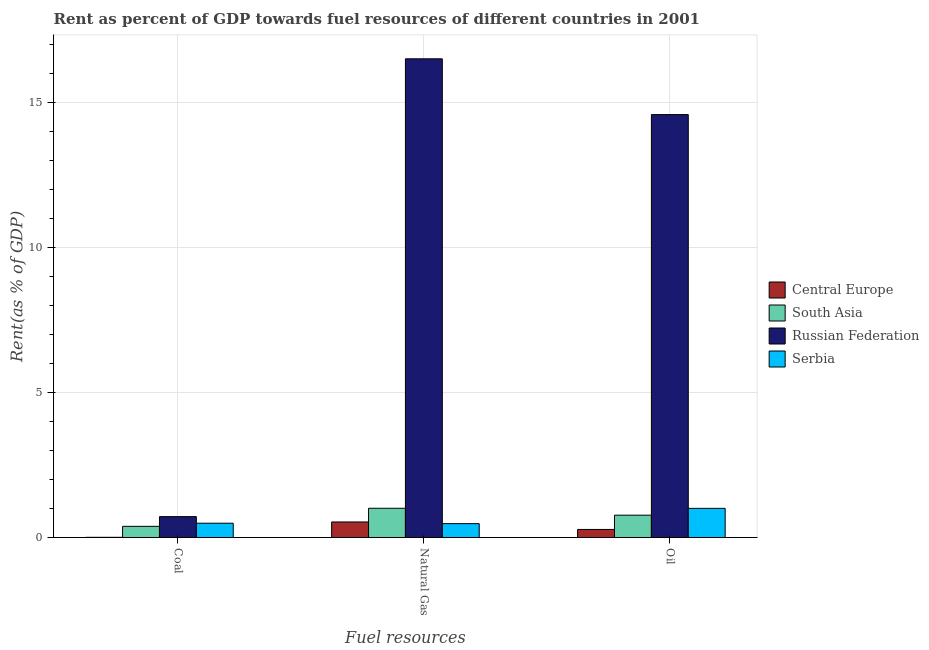How many different coloured bars are there?
Your response must be concise. 4. Are the number of bars per tick equal to the number of legend labels?
Your response must be concise. Yes. Are the number of bars on each tick of the X-axis equal?
Provide a succinct answer. Yes. How many bars are there on the 3rd tick from the right?
Offer a very short reply. 4. What is the label of the 1st group of bars from the left?
Ensure brevity in your answer.  Coal. What is the rent towards natural gas in Russian Federation?
Provide a succinct answer. 16.5. Across all countries, what is the maximum rent towards oil?
Provide a short and direct response. 14.57. Across all countries, what is the minimum rent towards coal?
Your answer should be very brief. 0.01. In which country was the rent towards coal maximum?
Provide a succinct answer. Russian Federation. In which country was the rent towards oil minimum?
Offer a terse response. Central Europe. What is the total rent towards natural gas in the graph?
Keep it short and to the point. 18.52. What is the difference between the rent towards coal in Central Europe and that in Russian Federation?
Keep it short and to the point. -0.71. What is the difference between the rent towards natural gas in Serbia and the rent towards oil in South Asia?
Keep it short and to the point. -0.29. What is the average rent towards coal per country?
Your answer should be compact. 0.4. What is the difference between the rent towards coal and rent towards natural gas in Serbia?
Offer a terse response. 0.01. What is the ratio of the rent towards oil in Central Europe to that in South Asia?
Ensure brevity in your answer.  0.36. Is the rent towards oil in Serbia less than that in South Asia?
Provide a succinct answer. No. Is the difference between the rent towards coal in Central Europe and South Asia greater than the difference between the rent towards oil in Central Europe and South Asia?
Offer a very short reply. Yes. What is the difference between the highest and the second highest rent towards natural gas?
Offer a very short reply. 15.49. What is the difference between the highest and the lowest rent towards coal?
Your response must be concise. 0.71. Is the sum of the rent towards coal in Russian Federation and Central Europe greater than the maximum rent towards natural gas across all countries?
Your answer should be very brief. No. What does the 4th bar from the left in Natural Gas represents?
Offer a very short reply. Serbia. What does the 2nd bar from the right in Coal represents?
Make the answer very short. Russian Federation. Are the values on the major ticks of Y-axis written in scientific E-notation?
Your answer should be very brief. No. Does the graph contain any zero values?
Your response must be concise. No. Does the graph contain grids?
Your answer should be very brief. Yes. How are the legend labels stacked?
Your answer should be compact. Vertical. What is the title of the graph?
Offer a very short reply. Rent as percent of GDP towards fuel resources of different countries in 2001. What is the label or title of the X-axis?
Give a very brief answer. Fuel resources. What is the label or title of the Y-axis?
Your answer should be very brief. Rent(as % of GDP). What is the Rent(as % of GDP) in Central Europe in Coal?
Offer a terse response. 0.01. What is the Rent(as % of GDP) in South Asia in Coal?
Ensure brevity in your answer.  0.38. What is the Rent(as % of GDP) in Russian Federation in Coal?
Provide a succinct answer. 0.72. What is the Rent(as % of GDP) of Serbia in Coal?
Offer a very short reply. 0.49. What is the Rent(as % of GDP) in Central Europe in Natural Gas?
Provide a succinct answer. 0.53. What is the Rent(as % of GDP) of South Asia in Natural Gas?
Give a very brief answer. 1.01. What is the Rent(as % of GDP) of Russian Federation in Natural Gas?
Offer a very short reply. 16.5. What is the Rent(as % of GDP) in Serbia in Natural Gas?
Make the answer very short. 0.48. What is the Rent(as % of GDP) in Central Europe in Oil?
Ensure brevity in your answer.  0.28. What is the Rent(as % of GDP) of South Asia in Oil?
Your answer should be compact. 0.77. What is the Rent(as % of GDP) in Russian Federation in Oil?
Offer a terse response. 14.57. What is the Rent(as % of GDP) in Serbia in Oil?
Offer a terse response. 1. Across all Fuel resources, what is the maximum Rent(as % of GDP) of Central Europe?
Offer a very short reply. 0.53. Across all Fuel resources, what is the maximum Rent(as % of GDP) in South Asia?
Offer a terse response. 1.01. Across all Fuel resources, what is the maximum Rent(as % of GDP) of Russian Federation?
Your answer should be very brief. 16.5. Across all Fuel resources, what is the maximum Rent(as % of GDP) in Serbia?
Offer a terse response. 1. Across all Fuel resources, what is the minimum Rent(as % of GDP) in Central Europe?
Provide a short and direct response. 0.01. Across all Fuel resources, what is the minimum Rent(as % of GDP) in South Asia?
Make the answer very short. 0.38. Across all Fuel resources, what is the minimum Rent(as % of GDP) of Russian Federation?
Your answer should be very brief. 0.72. Across all Fuel resources, what is the minimum Rent(as % of GDP) in Serbia?
Offer a terse response. 0.48. What is the total Rent(as % of GDP) in Central Europe in the graph?
Provide a short and direct response. 0.82. What is the total Rent(as % of GDP) in South Asia in the graph?
Keep it short and to the point. 2.16. What is the total Rent(as % of GDP) of Russian Federation in the graph?
Keep it short and to the point. 31.79. What is the total Rent(as % of GDP) in Serbia in the graph?
Offer a terse response. 1.97. What is the difference between the Rent(as % of GDP) in Central Europe in Coal and that in Natural Gas?
Your answer should be very brief. -0.53. What is the difference between the Rent(as % of GDP) of South Asia in Coal and that in Natural Gas?
Offer a very short reply. -0.62. What is the difference between the Rent(as % of GDP) of Russian Federation in Coal and that in Natural Gas?
Keep it short and to the point. -15.78. What is the difference between the Rent(as % of GDP) of Serbia in Coal and that in Natural Gas?
Your response must be concise. 0.01. What is the difference between the Rent(as % of GDP) in Central Europe in Coal and that in Oil?
Offer a terse response. -0.27. What is the difference between the Rent(as % of GDP) in South Asia in Coal and that in Oil?
Offer a terse response. -0.39. What is the difference between the Rent(as % of GDP) in Russian Federation in Coal and that in Oil?
Provide a succinct answer. -13.86. What is the difference between the Rent(as % of GDP) of Serbia in Coal and that in Oil?
Your answer should be very brief. -0.51. What is the difference between the Rent(as % of GDP) of Central Europe in Natural Gas and that in Oil?
Your answer should be very brief. 0.26. What is the difference between the Rent(as % of GDP) of South Asia in Natural Gas and that in Oil?
Offer a very short reply. 0.24. What is the difference between the Rent(as % of GDP) in Russian Federation in Natural Gas and that in Oil?
Provide a succinct answer. 1.92. What is the difference between the Rent(as % of GDP) in Serbia in Natural Gas and that in Oil?
Your response must be concise. -0.53. What is the difference between the Rent(as % of GDP) of Central Europe in Coal and the Rent(as % of GDP) of South Asia in Natural Gas?
Keep it short and to the point. -1. What is the difference between the Rent(as % of GDP) of Central Europe in Coal and the Rent(as % of GDP) of Russian Federation in Natural Gas?
Ensure brevity in your answer.  -16.49. What is the difference between the Rent(as % of GDP) in Central Europe in Coal and the Rent(as % of GDP) in Serbia in Natural Gas?
Your response must be concise. -0.47. What is the difference between the Rent(as % of GDP) of South Asia in Coal and the Rent(as % of GDP) of Russian Federation in Natural Gas?
Offer a very short reply. -16.11. What is the difference between the Rent(as % of GDP) of South Asia in Coal and the Rent(as % of GDP) of Serbia in Natural Gas?
Offer a terse response. -0.09. What is the difference between the Rent(as % of GDP) of Russian Federation in Coal and the Rent(as % of GDP) of Serbia in Natural Gas?
Your response must be concise. 0.24. What is the difference between the Rent(as % of GDP) of Central Europe in Coal and the Rent(as % of GDP) of South Asia in Oil?
Offer a very short reply. -0.76. What is the difference between the Rent(as % of GDP) of Central Europe in Coal and the Rent(as % of GDP) of Russian Federation in Oil?
Offer a very short reply. -14.57. What is the difference between the Rent(as % of GDP) of Central Europe in Coal and the Rent(as % of GDP) of Serbia in Oil?
Ensure brevity in your answer.  -1. What is the difference between the Rent(as % of GDP) of South Asia in Coal and the Rent(as % of GDP) of Russian Federation in Oil?
Provide a succinct answer. -14.19. What is the difference between the Rent(as % of GDP) in South Asia in Coal and the Rent(as % of GDP) in Serbia in Oil?
Offer a very short reply. -0.62. What is the difference between the Rent(as % of GDP) in Russian Federation in Coal and the Rent(as % of GDP) in Serbia in Oil?
Give a very brief answer. -0.28. What is the difference between the Rent(as % of GDP) in Central Europe in Natural Gas and the Rent(as % of GDP) in South Asia in Oil?
Ensure brevity in your answer.  -0.23. What is the difference between the Rent(as % of GDP) in Central Europe in Natural Gas and the Rent(as % of GDP) in Russian Federation in Oil?
Your response must be concise. -14.04. What is the difference between the Rent(as % of GDP) in Central Europe in Natural Gas and the Rent(as % of GDP) in Serbia in Oil?
Give a very brief answer. -0.47. What is the difference between the Rent(as % of GDP) in South Asia in Natural Gas and the Rent(as % of GDP) in Russian Federation in Oil?
Your response must be concise. -13.57. What is the difference between the Rent(as % of GDP) of South Asia in Natural Gas and the Rent(as % of GDP) of Serbia in Oil?
Provide a succinct answer. 0. What is the difference between the Rent(as % of GDP) in Russian Federation in Natural Gas and the Rent(as % of GDP) in Serbia in Oil?
Keep it short and to the point. 15.49. What is the average Rent(as % of GDP) of Central Europe per Fuel resources?
Your response must be concise. 0.27. What is the average Rent(as % of GDP) of South Asia per Fuel resources?
Give a very brief answer. 0.72. What is the average Rent(as % of GDP) of Russian Federation per Fuel resources?
Ensure brevity in your answer.  10.6. What is the average Rent(as % of GDP) in Serbia per Fuel resources?
Make the answer very short. 0.66. What is the difference between the Rent(as % of GDP) in Central Europe and Rent(as % of GDP) in South Asia in Coal?
Give a very brief answer. -0.38. What is the difference between the Rent(as % of GDP) in Central Europe and Rent(as % of GDP) in Russian Federation in Coal?
Provide a short and direct response. -0.71. What is the difference between the Rent(as % of GDP) in Central Europe and Rent(as % of GDP) in Serbia in Coal?
Your answer should be very brief. -0.49. What is the difference between the Rent(as % of GDP) of South Asia and Rent(as % of GDP) of Russian Federation in Coal?
Make the answer very short. -0.34. What is the difference between the Rent(as % of GDP) of South Asia and Rent(as % of GDP) of Serbia in Coal?
Provide a succinct answer. -0.11. What is the difference between the Rent(as % of GDP) of Russian Federation and Rent(as % of GDP) of Serbia in Coal?
Make the answer very short. 0.23. What is the difference between the Rent(as % of GDP) of Central Europe and Rent(as % of GDP) of South Asia in Natural Gas?
Offer a terse response. -0.47. What is the difference between the Rent(as % of GDP) of Central Europe and Rent(as % of GDP) of Russian Federation in Natural Gas?
Your answer should be compact. -15.96. What is the difference between the Rent(as % of GDP) in Central Europe and Rent(as % of GDP) in Serbia in Natural Gas?
Make the answer very short. 0.06. What is the difference between the Rent(as % of GDP) of South Asia and Rent(as % of GDP) of Russian Federation in Natural Gas?
Offer a very short reply. -15.49. What is the difference between the Rent(as % of GDP) of South Asia and Rent(as % of GDP) of Serbia in Natural Gas?
Offer a very short reply. 0.53. What is the difference between the Rent(as % of GDP) of Russian Federation and Rent(as % of GDP) of Serbia in Natural Gas?
Offer a very short reply. 16.02. What is the difference between the Rent(as % of GDP) in Central Europe and Rent(as % of GDP) in South Asia in Oil?
Provide a succinct answer. -0.49. What is the difference between the Rent(as % of GDP) in Central Europe and Rent(as % of GDP) in Russian Federation in Oil?
Keep it short and to the point. -14.3. What is the difference between the Rent(as % of GDP) in Central Europe and Rent(as % of GDP) in Serbia in Oil?
Provide a succinct answer. -0.73. What is the difference between the Rent(as % of GDP) in South Asia and Rent(as % of GDP) in Russian Federation in Oil?
Your answer should be compact. -13.81. What is the difference between the Rent(as % of GDP) of South Asia and Rent(as % of GDP) of Serbia in Oil?
Keep it short and to the point. -0.23. What is the difference between the Rent(as % of GDP) in Russian Federation and Rent(as % of GDP) in Serbia in Oil?
Ensure brevity in your answer.  13.57. What is the ratio of the Rent(as % of GDP) of Central Europe in Coal to that in Natural Gas?
Your answer should be very brief. 0.01. What is the ratio of the Rent(as % of GDP) of South Asia in Coal to that in Natural Gas?
Keep it short and to the point. 0.38. What is the ratio of the Rent(as % of GDP) of Russian Federation in Coal to that in Natural Gas?
Provide a succinct answer. 0.04. What is the ratio of the Rent(as % of GDP) of Serbia in Coal to that in Natural Gas?
Your answer should be very brief. 1.03. What is the ratio of the Rent(as % of GDP) of Central Europe in Coal to that in Oil?
Offer a terse response. 0.02. What is the ratio of the Rent(as % of GDP) of South Asia in Coal to that in Oil?
Keep it short and to the point. 0.5. What is the ratio of the Rent(as % of GDP) in Russian Federation in Coal to that in Oil?
Give a very brief answer. 0.05. What is the ratio of the Rent(as % of GDP) in Serbia in Coal to that in Oil?
Offer a terse response. 0.49. What is the ratio of the Rent(as % of GDP) in Central Europe in Natural Gas to that in Oil?
Make the answer very short. 1.93. What is the ratio of the Rent(as % of GDP) in South Asia in Natural Gas to that in Oil?
Provide a short and direct response. 1.31. What is the ratio of the Rent(as % of GDP) in Russian Federation in Natural Gas to that in Oil?
Ensure brevity in your answer.  1.13. What is the ratio of the Rent(as % of GDP) in Serbia in Natural Gas to that in Oil?
Offer a very short reply. 0.48. What is the difference between the highest and the second highest Rent(as % of GDP) in Central Europe?
Give a very brief answer. 0.26. What is the difference between the highest and the second highest Rent(as % of GDP) in South Asia?
Offer a terse response. 0.24. What is the difference between the highest and the second highest Rent(as % of GDP) in Russian Federation?
Provide a short and direct response. 1.92. What is the difference between the highest and the second highest Rent(as % of GDP) in Serbia?
Your answer should be compact. 0.51. What is the difference between the highest and the lowest Rent(as % of GDP) in Central Europe?
Offer a terse response. 0.53. What is the difference between the highest and the lowest Rent(as % of GDP) in South Asia?
Provide a succinct answer. 0.62. What is the difference between the highest and the lowest Rent(as % of GDP) in Russian Federation?
Provide a succinct answer. 15.78. What is the difference between the highest and the lowest Rent(as % of GDP) of Serbia?
Offer a very short reply. 0.53. 